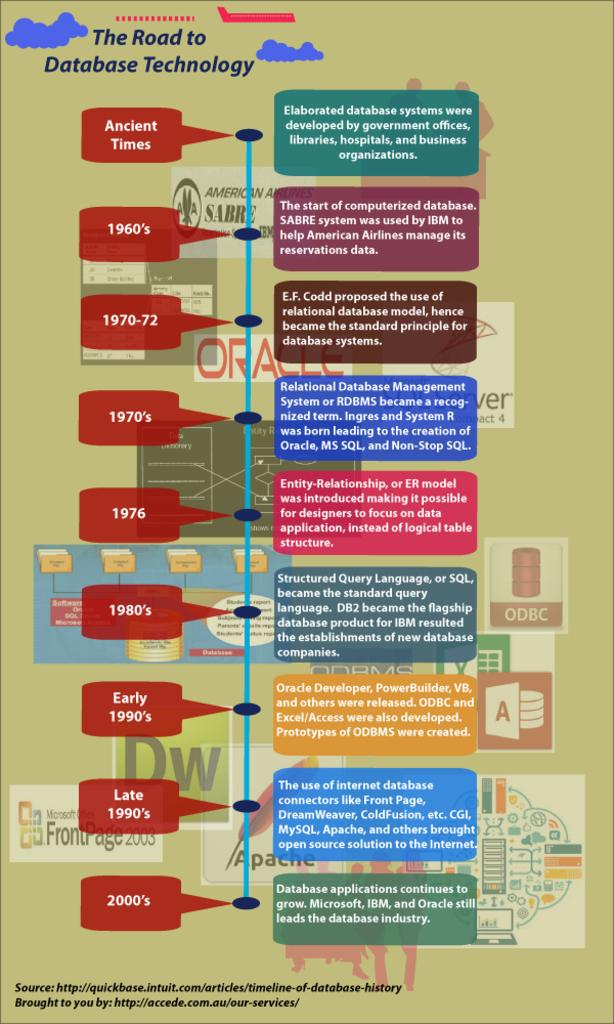How many friends are holding cream in the image? There is no image provided, and therefore no friends or cream can be observed. 